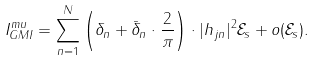Convert formula to latex. <formula><loc_0><loc_0><loc_500><loc_500>I _ { G M I } ^ { m u } = \sum _ { n = 1 } ^ { N } \left ( \delta _ { n } + \bar { \delta } _ { n } \cdot \frac { 2 } { \pi } \right ) \cdot | h _ { j n } | ^ { 2 } \mathcal { E } _ { s } + o ( \mathcal { E } _ { s } ) .</formula> 